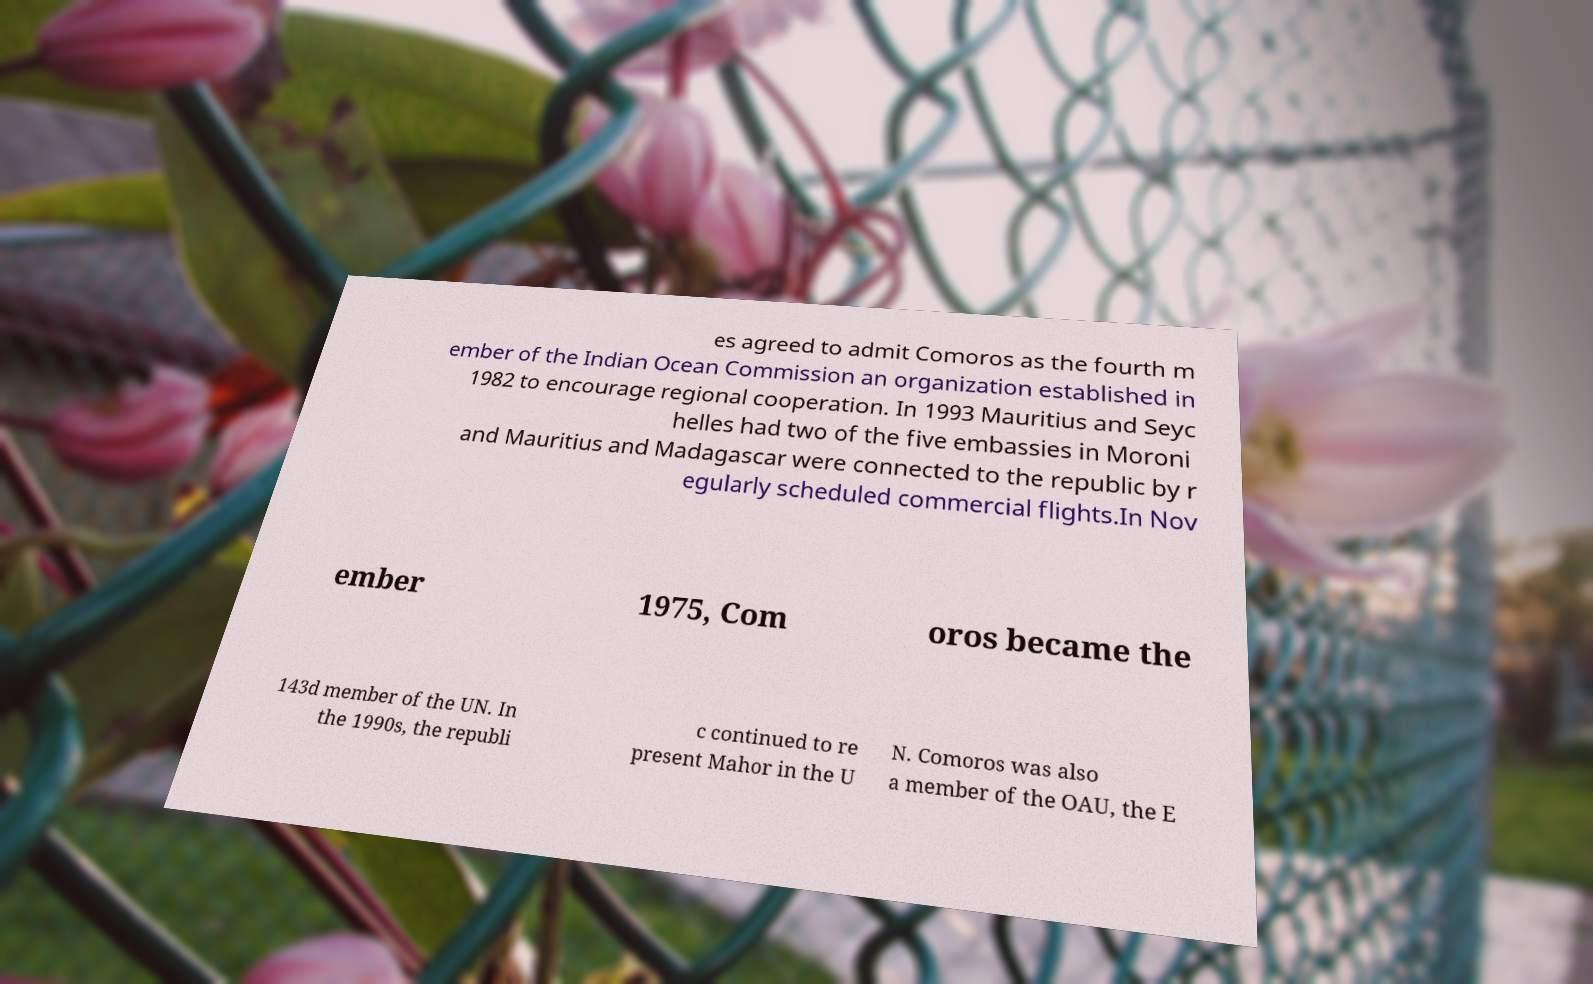Can you read and provide the text displayed in the image?This photo seems to have some interesting text. Can you extract and type it out for me? es agreed to admit Comoros as the fourth m ember of the Indian Ocean Commission an organization established in 1982 to encourage regional cooperation. In 1993 Mauritius and Seyc helles had two of the five embassies in Moroni and Mauritius and Madagascar were connected to the republic by r egularly scheduled commercial flights.In Nov ember 1975, Com oros became the 143d member of the UN. In the 1990s, the republi c continued to re present Mahor in the U N. Comoros was also a member of the OAU, the E 